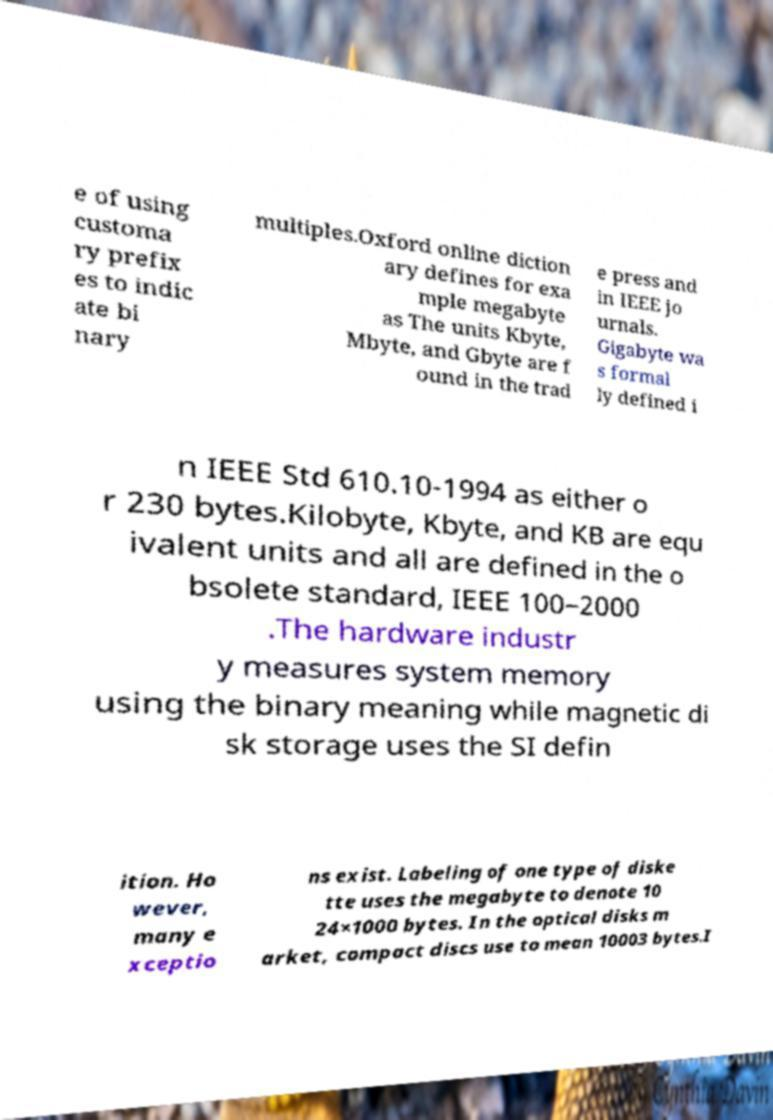Could you extract and type out the text from this image? e of using customa ry prefix es to indic ate bi nary multiples.Oxford online diction ary defines for exa mple megabyte as The units Kbyte, Mbyte, and Gbyte are f ound in the trad e press and in IEEE jo urnals. Gigabyte wa s formal ly defined i n IEEE Std 610.10-1994 as either o r 230 bytes.Kilobyte, Kbyte, and KB are equ ivalent units and all are defined in the o bsolete standard, IEEE 100–2000 .The hardware industr y measures system memory using the binary meaning while magnetic di sk storage uses the SI defin ition. Ho wever, many e xceptio ns exist. Labeling of one type of diske tte uses the megabyte to denote 10 24×1000 bytes. In the optical disks m arket, compact discs use to mean 10003 bytes.I 